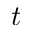Convert formula to latex. <formula><loc_0><loc_0><loc_500><loc_500>t</formula> 